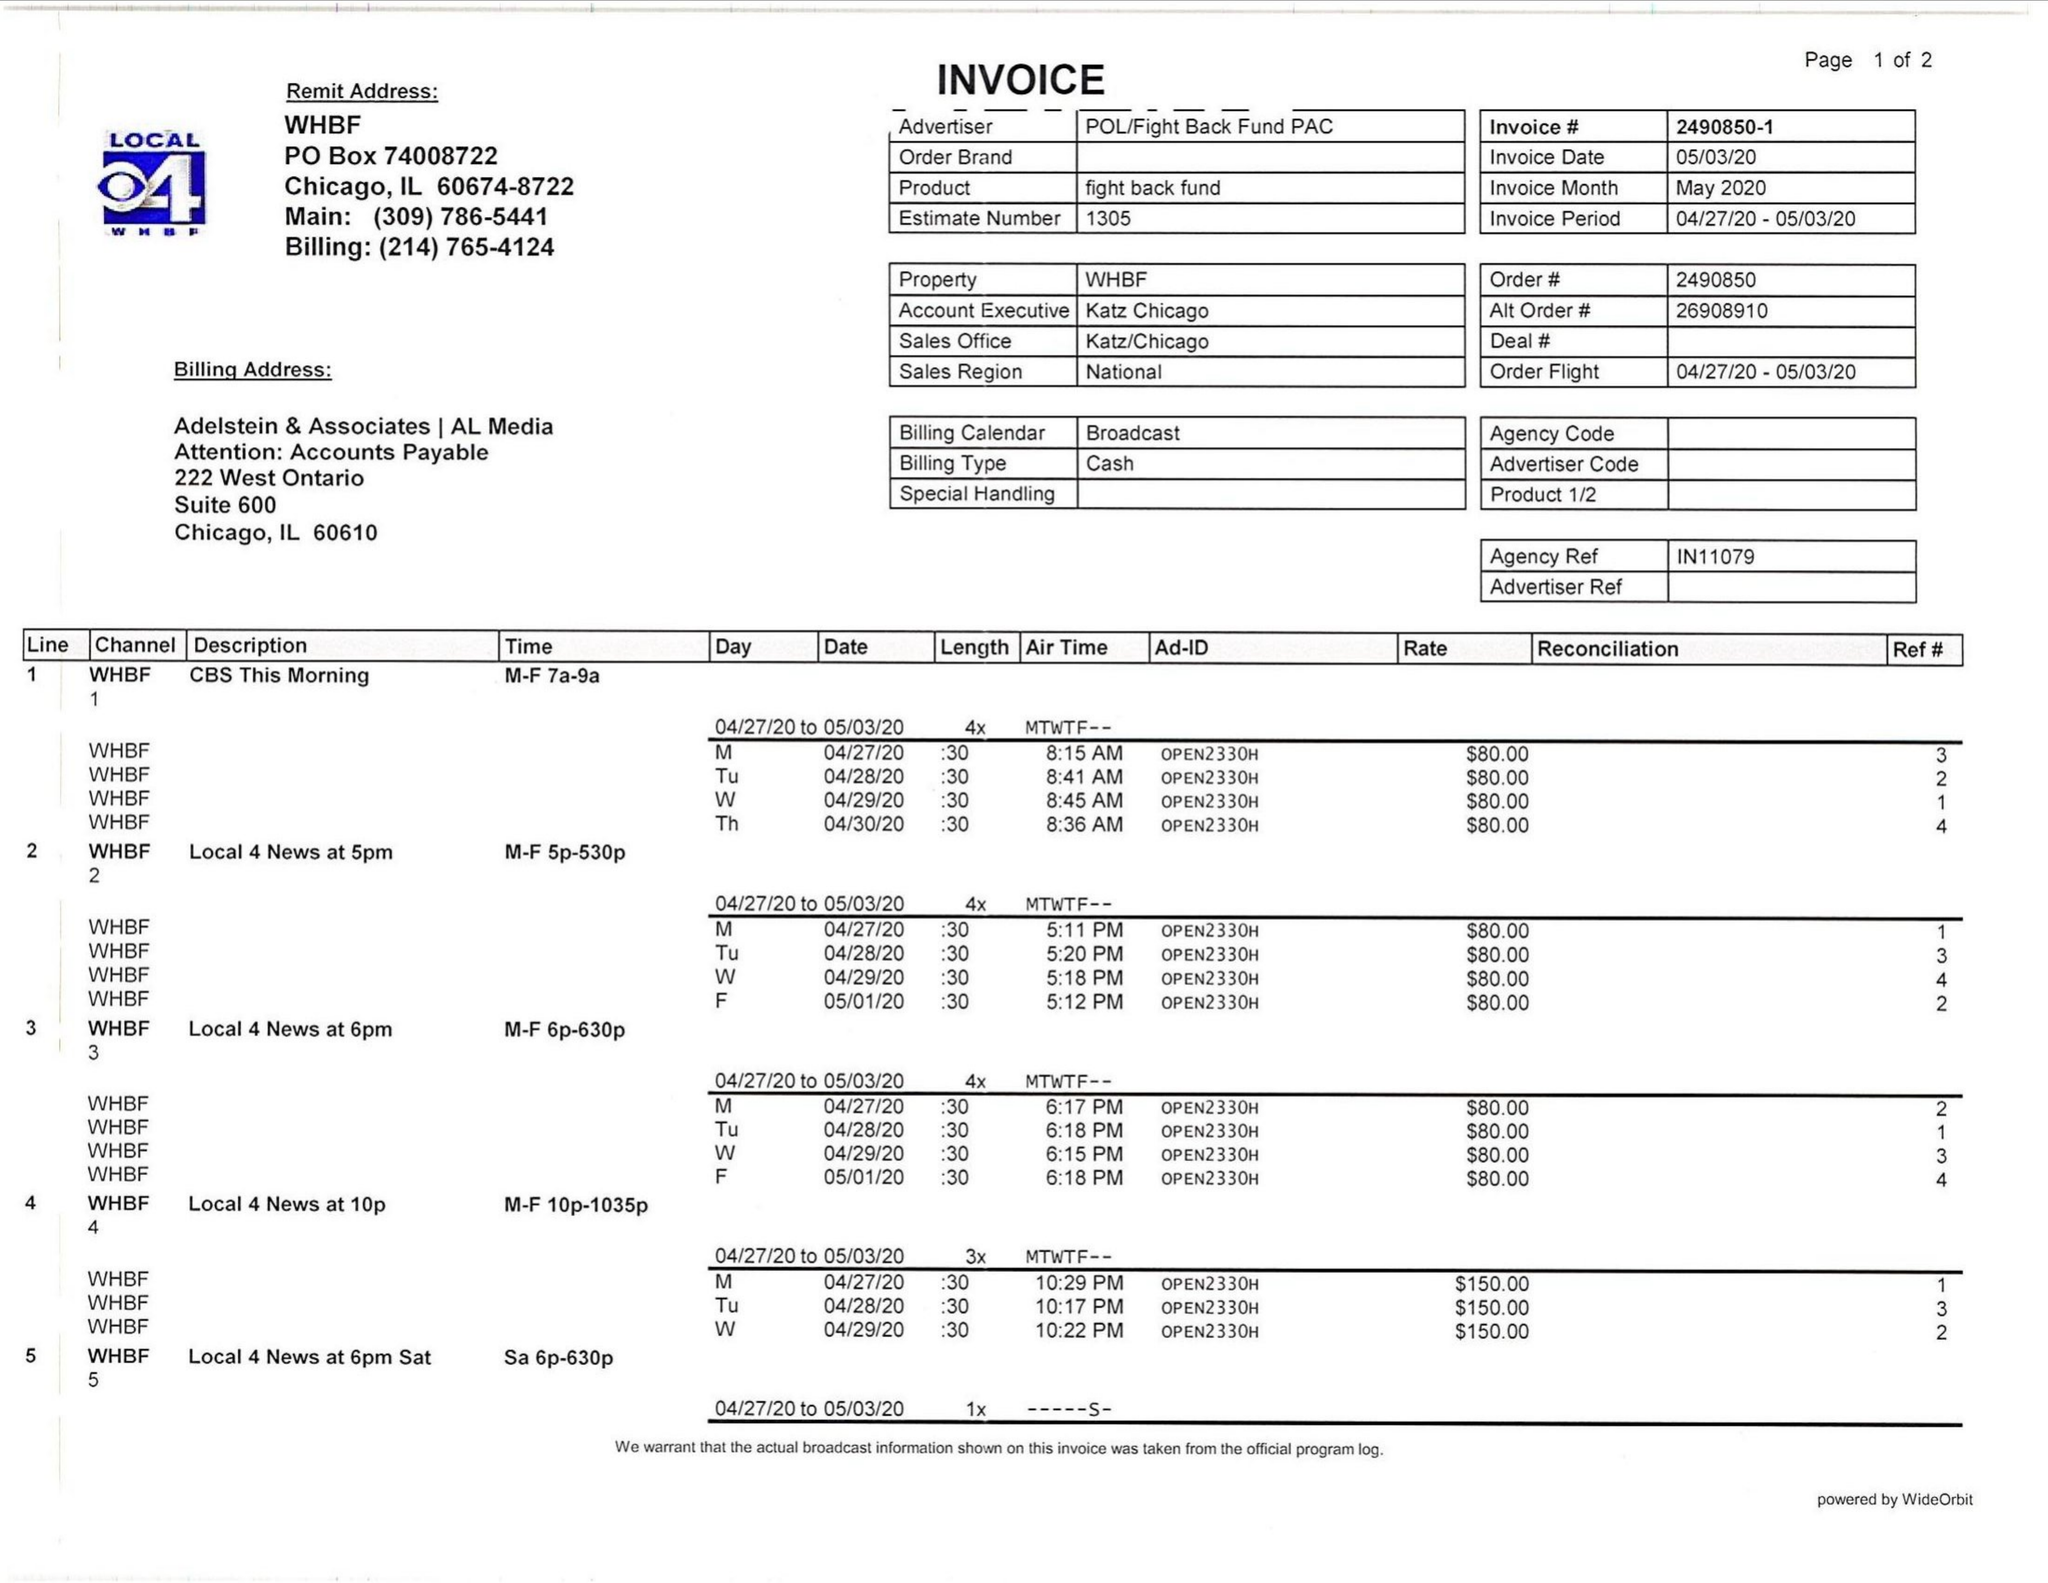What is the value for the flight_from?
Answer the question using a single word or phrase. 04/27/20 